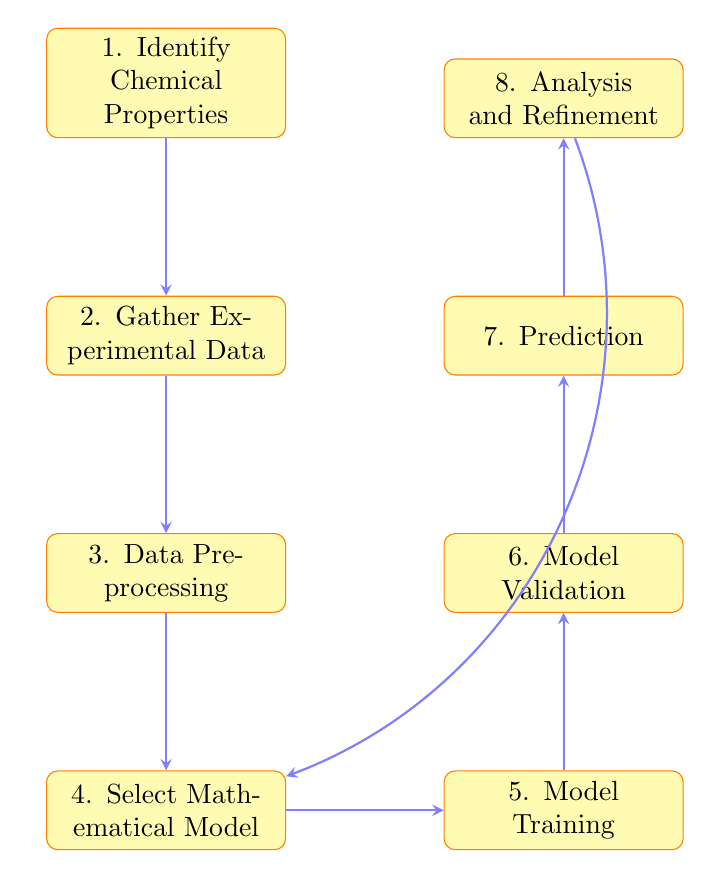What is the first step in the flow chart? The flow chart begins with the node labeled "1. Identify Chemical Properties," indicating that this is the initial step in the process.
Answer: Identify Chemical Properties How many total nodes are in the diagram? Counting all the distinct steps represented in the flow chart, there are a total of eight nodes involved in the process.
Answer: Eight Which two steps come after "Data Preprocessing"? Looking at the flow, the steps following "Data Preprocessing" are "4. Select Mathematical Model" and then "5. Model Training," indicating the progression of the methodology.
Answer: Select Mathematical Model and Model Training What is the last step in the diagram? The last step in the flow chart is labeled "8. Analysis and Refinement," which indicates this is where the results are examined after predictions.
Answer: Analysis and Refinement Which node comes before "Model Validation"? Reviewing the flow sequence, "5. Model Training" directly precedes "6. Model Validation," showing the order of operations.
Answer: Model Training How does "Analysis and Refinement" connect to "Select Mathematical Model"? The flow chart shows that "Analysis and Refinement" has a bending arrow that loops back to "Select Mathematical Model," suggesting that the analysis may inform adjustments to the model.
Answer: Bending arrow loops back What type of model can be selected in the fourth step? The fourth step mentions that various models can be chosen, specifically identifying options like regression, neural networks, and machine learning algorithms.
Answer: Regression, neural networks, machine learning algorithms Which node indicates the use of models for new predictions? The node "7. Prediction" clearly indicates the stage where the validated model is deployed to make predictions about new chemical compounds.
Answer: Prediction 